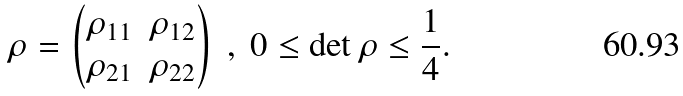<formula> <loc_0><loc_0><loc_500><loc_500>\rho = \begin{pmatrix} \rho _ { 1 1 } & \rho _ { 1 2 } \\ \rho _ { 2 1 } & \rho _ { 2 2 } \end{pmatrix} \ , \ 0 \leq \det \rho \leq \frac { 1 } { 4 } .</formula> 